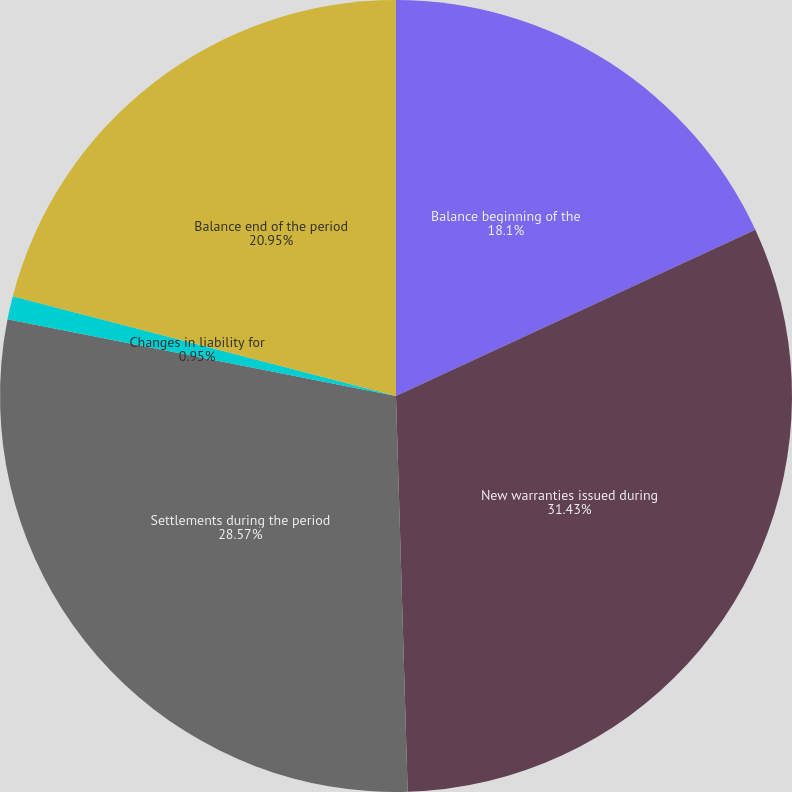<chart> <loc_0><loc_0><loc_500><loc_500><pie_chart><fcel>Balance beginning of the<fcel>New warranties issued during<fcel>Settlements during the period<fcel>Changes in liability for<fcel>Balance end of the period<nl><fcel>18.1%<fcel>31.43%<fcel>28.57%<fcel>0.95%<fcel>20.95%<nl></chart> 